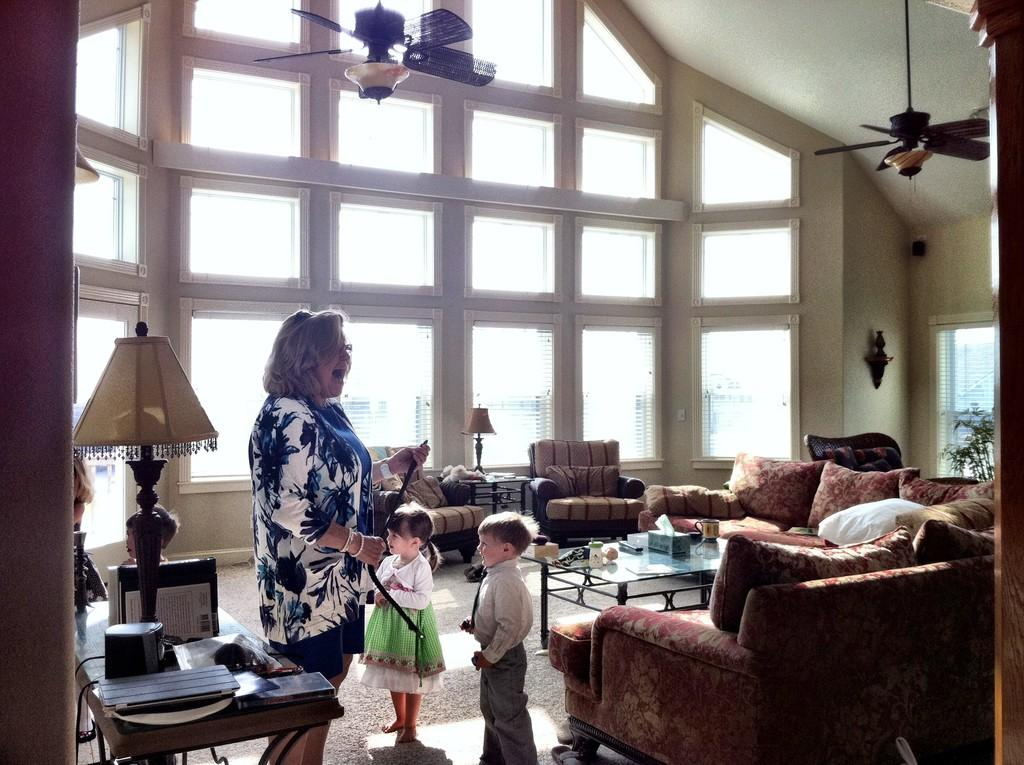Who is present in the image? There is a woman and two children in the image. What can be seen on the right side of the image? There is a sofa on the right side of the image. What type of toothbrush is the woman using in the image? There is no toothbrush present in the image. What kind of flower is on the sofa in the image? There are no flowers visible on the sofa in the image. 